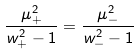Convert formula to latex. <formula><loc_0><loc_0><loc_500><loc_500>\frac { \mu _ { + } ^ { 2 } } { w _ { + } ^ { 2 } - 1 } = \frac { \mu _ { - } ^ { 2 } } { w _ { - } ^ { 2 } - 1 }</formula> 